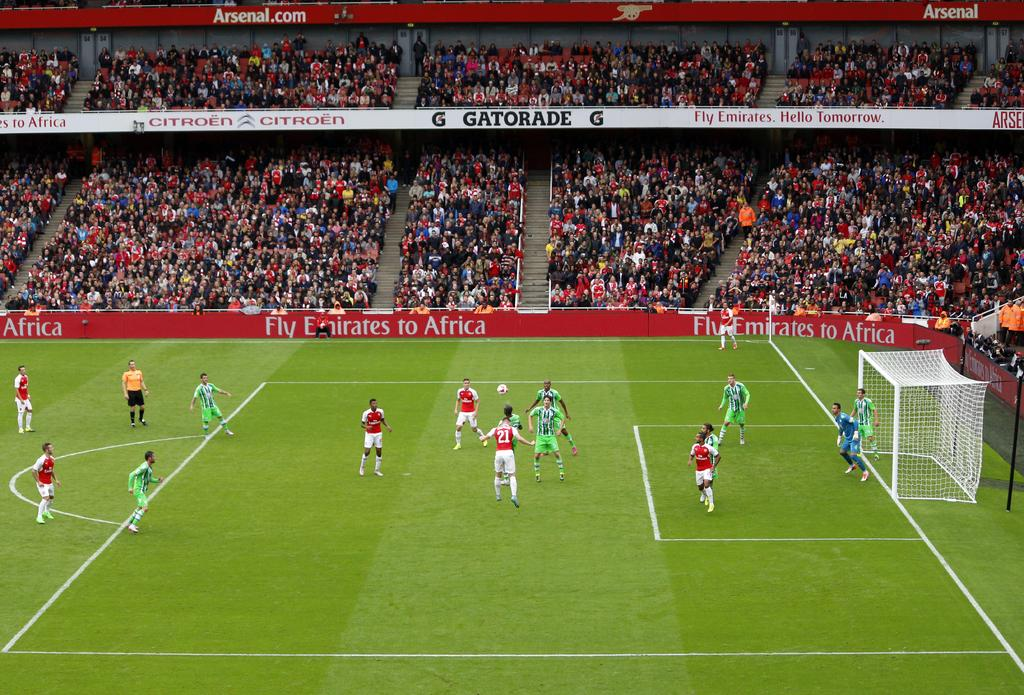What are the people in the image doing? There are people playing in a ground, and there are people sitting and watching a match. Can you describe the activity taking place in the image? The people are playing a match, and others are watching the game. Are there any giants playing in the match in the image? No, there are no giants present in the image. What type of pot can be seen in the park near the playing ground? There is no park or pot mentioned in the image; it only shows people playing and watching a match. 